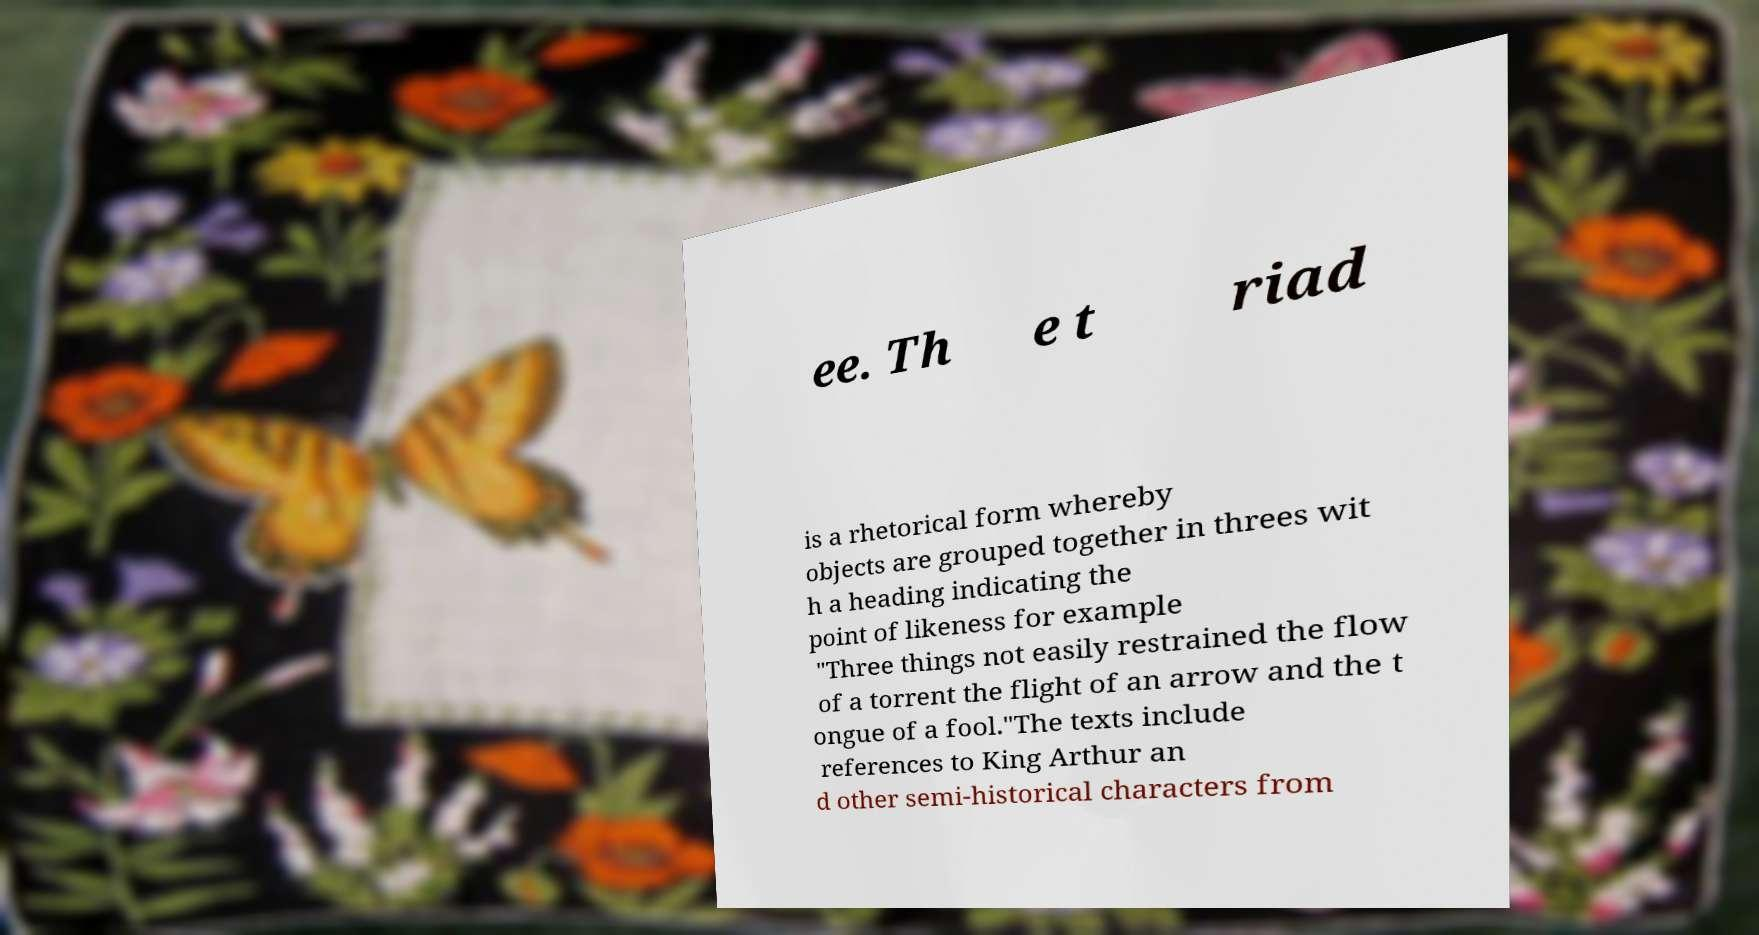Could you extract and type out the text from this image? ee. Th e t riad is a rhetorical form whereby objects are grouped together in threes wit h a heading indicating the point of likeness for example "Three things not easily restrained the flow of a torrent the flight of an arrow and the t ongue of a fool."The texts include references to King Arthur an d other semi-historical characters from 